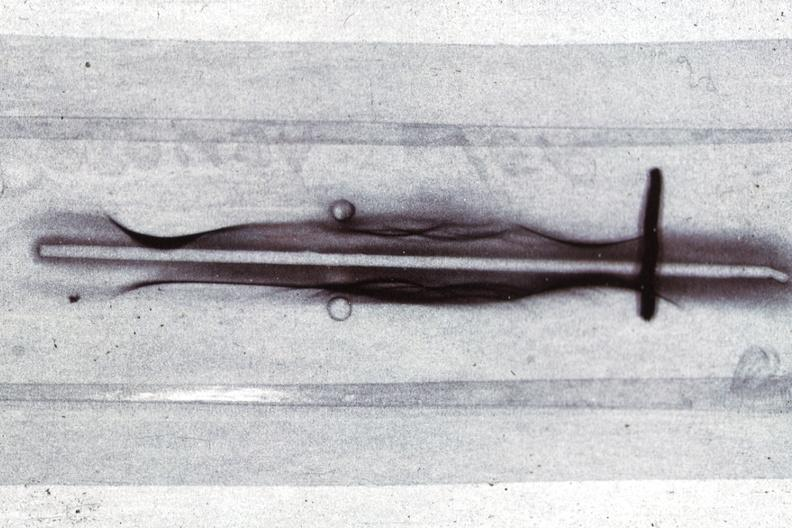what is present?
Answer the question using a single word or phrase. Monoclonal gammopathy 